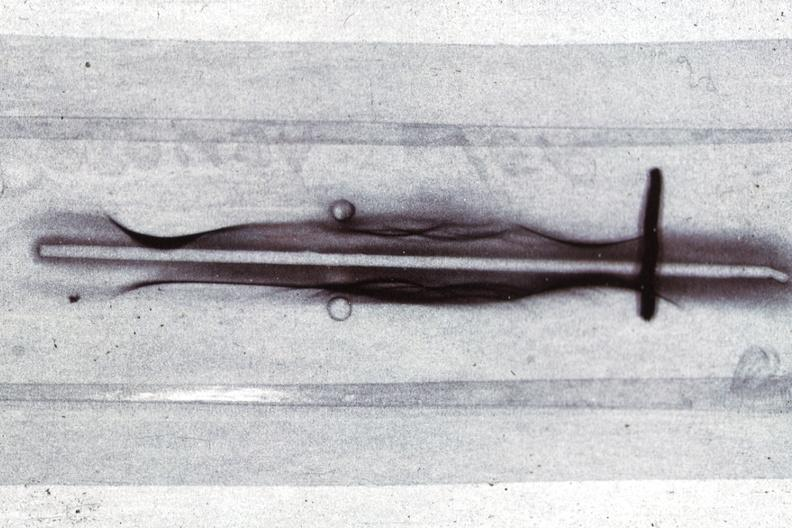what is present?
Answer the question using a single word or phrase. Monoclonal gammopathy 